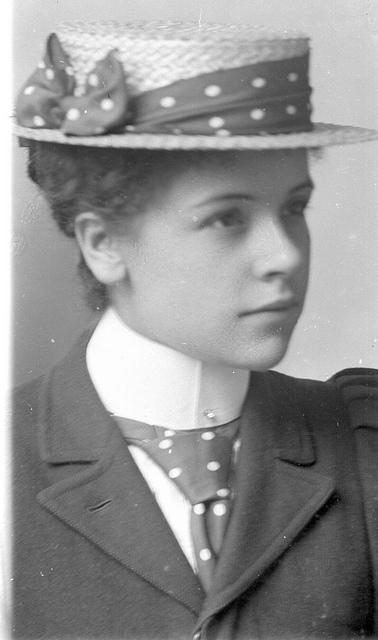How many black donut are there this images?
Give a very brief answer. 0. 